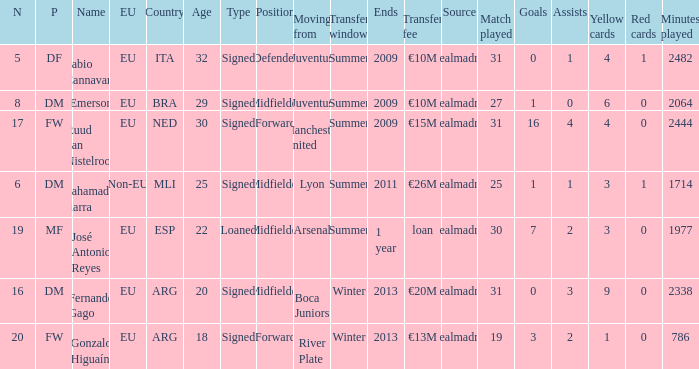What is the type of the player whose transfer fee was €20m? Signed. 